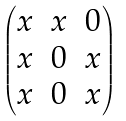<formula> <loc_0><loc_0><loc_500><loc_500>\begin{pmatrix} x & x & 0 \\ x & 0 & x \\ x & 0 & x \\ \end{pmatrix}</formula> 